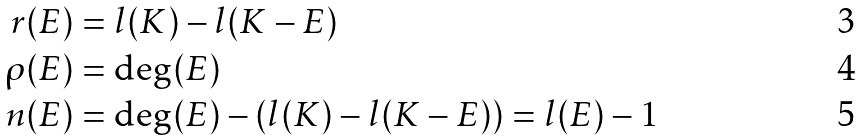Convert formula to latex. <formula><loc_0><loc_0><loc_500><loc_500>r ( E ) & = l ( K ) - l ( K - E ) \\ \rho ( E ) & = \deg ( E ) \\ n ( E ) & = \deg ( E ) - ( l ( K ) - l ( K - E ) ) = l ( E ) - 1</formula> 